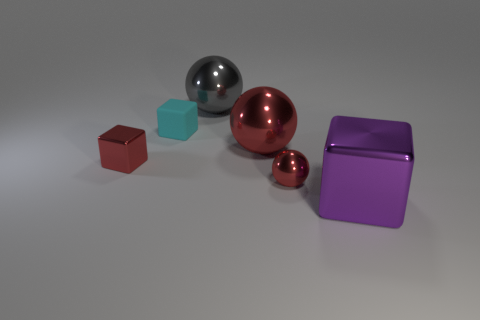Subtract all red balls. How many were subtracted if there are1red balls left? 1 Subtract all blue cubes. Subtract all yellow spheres. How many cubes are left? 3 Add 4 tiny objects. How many objects exist? 10 Add 1 big things. How many big things are left? 4 Add 3 cyan objects. How many cyan objects exist? 4 Subtract 0 cyan balls. How many objects are left? 6 Subtract all purple objects. Subtract all cyan things. How many objects are left? 4 